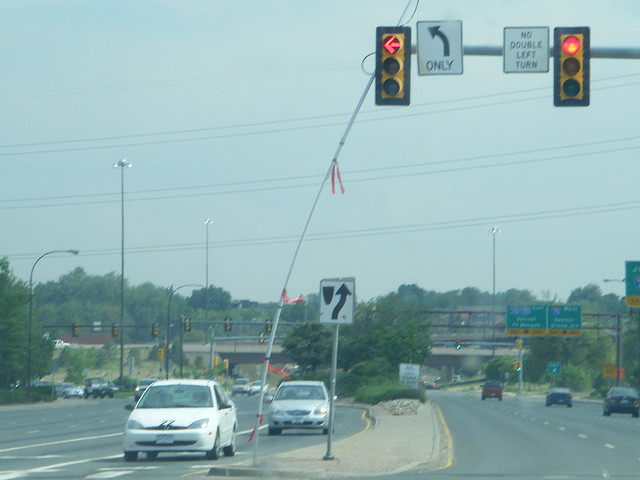Identify the text contained in this image. DOUBLE TURN ONLY 